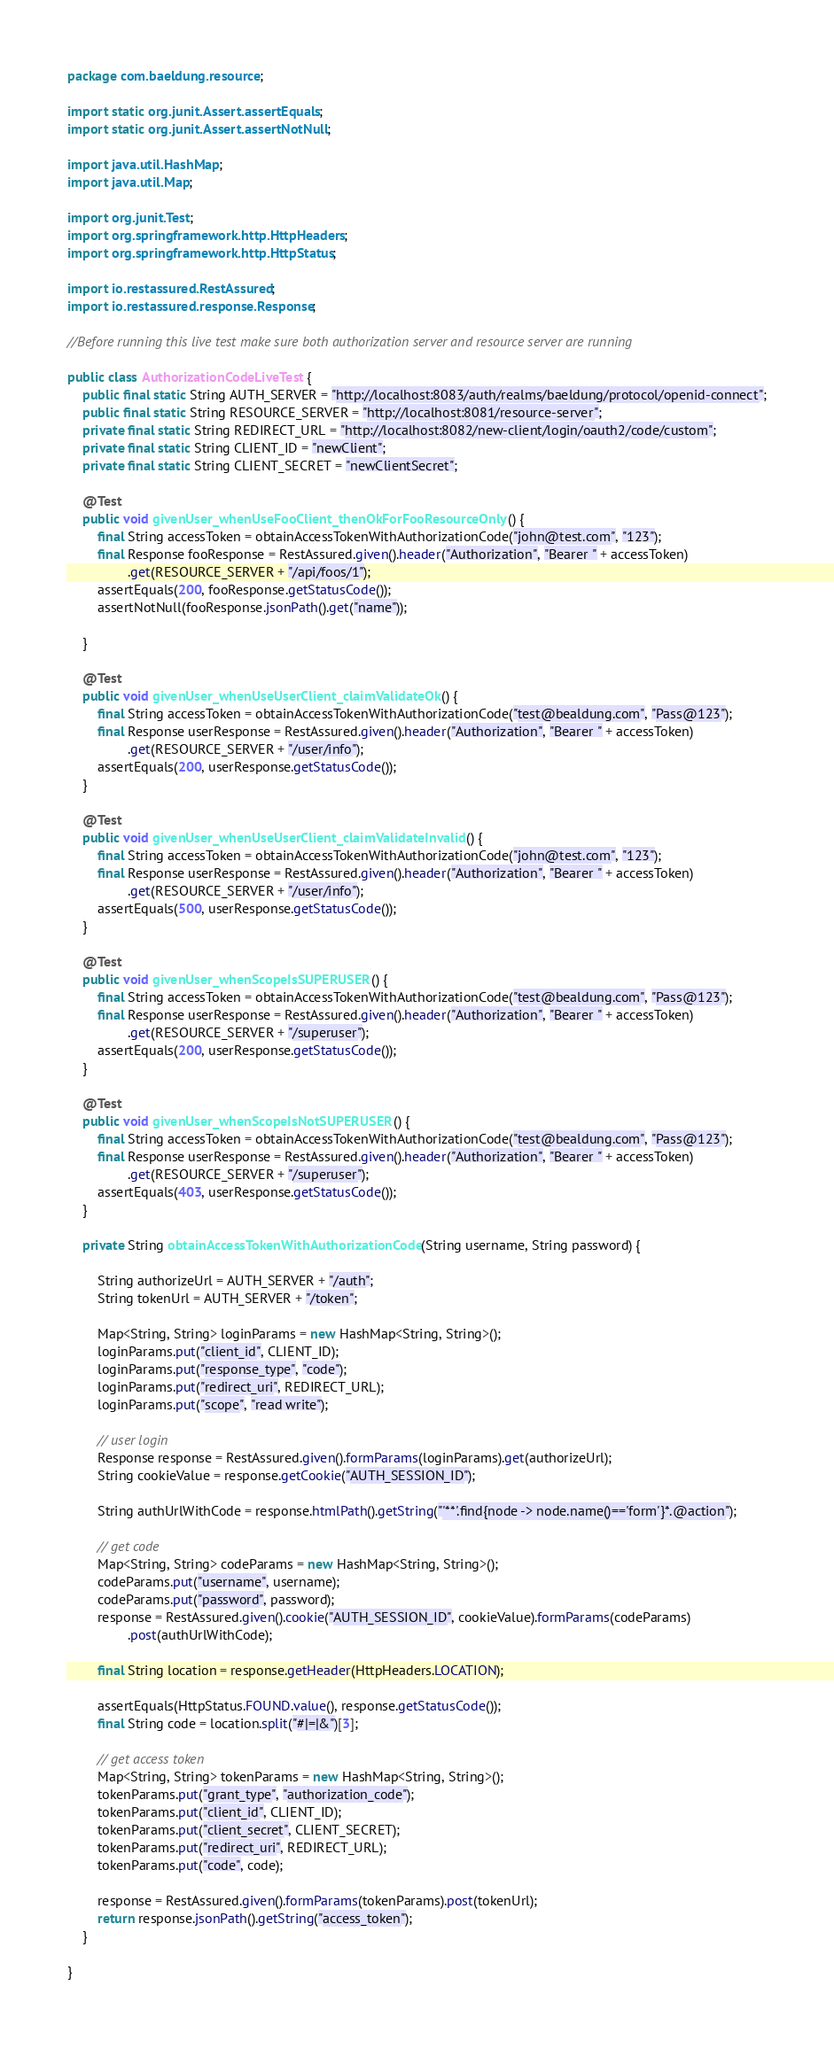<code> <loc_0><loc_0><loc_500><loc_500><_Java_>package com.baeldung.resource;

import static org.junit.Assert.assertEquals;
import static org.junit.Assert.assertNotNull;

import java.util.HashMap;
import java.util.Map;

import org.junit.Test;
import org.springframework.http.HttpHeaders;
import org.springframework.http.HttpStatus;

import io.restassured.RestAssured;
import io.restassured.response.Response;

//Before running this live test make sure both authorization server and resource server are running   

public class AuthorizationCodeLiveTest {
	public final static String AUTH_SERVER = "http://localhost:8083/auth/realms/baeldung/protocol/openid-connect";
	public final static String RESOURCE_SERVER = "http://localhost:8081/resource-server";
	private final static String REDIRECT_URL = "http://localhost:8082/new-client/login/oauth2/code/custom";
	private final static String CLIENT_ID = "newClient";
	private final static String CLIENT_SECRET = "newClientSecret";

	@Test
	public void givenUser_whenUseFooClient_thenOkForFooResourceOnly() {
		final String accessToken = obtainAccessTokenWithAuthorizationCode("john@test.com", "123");
		final Response fooResponse = RestAssured.given().header("Authorization", "Bearer " + accessToken)
				.get(RESOURCE_SERVER + "/api/foos/1");
		assertEquals(200, fooResponse.getStatusCode());
		assertNotNull(fooResponse.jsonPath().get("name"));

	}

	@Test
	public void givenUser_whenUseUserClient_claimValidateOk() {
		final String accessToken = obtainAccessTokenWithAuthorizationCode("test@bealdung.com", "Pass@123");
		final Response userResponse = RestAssured.given().header("Authorization", "Bearer " + accessToken)
				.get(RESOURCE_SERVER + "/user/info");
		assertEquals(200, userResponse.getStatusCode());
	}
	
	@Test
	public void givenUser_whenUseUserClient_claimValidateInvalid() {
		final String accessToken = obtainAccessTokenWithAuthorizationCode("john@test.com", "123");
		final Response userResponse = RestAssured.given().header("Authorization", "Bearer " + accessToken)
				.get(RESOURCE_SERVER + "/user/info");
		assertEquals(500, userResponse.getStatusCode());
	}
	
	@Test
	public void givenUser_whenScopeIsSUPERUSER() {
		final String accessToken = obtainAccessTokenWithAuthorizationCode("test@bealdung.com", "Pass@123");
		final Response userResponse = RestAssured.given().header("Authorization", "Bearer " + accessToken)
				.get(RESOURCE_SERVER + "/superuser");
		assertEquals(200, userResponse.getStatusCode());
	}
	
	@Test
	public void givenUser_whenScopeIsNotSUPERUSER() {
		final String accessToken = obtainAccessTokenWithAuthorizationCode("test@bealdung.com", "Pass@123");
		final Response userResponse = RestAssured.given().header("Authorization", "Bearer " + accessToken)
				.get(RESOURCE_SERVER + "/superuser");
		assertEquals(403, userResponse.getStatusCode());
	}

	private String obtainAccessTokenWithAuthorizationCode(String username, String password) {

		String authorizeUrl = AUTH_SERVER + "/auth";
		String tokenUrl = AUTH_SERVER + "/token";

		Map<String, String> loginParams = new HashMap<String, String>();
		loginParams.put("client_id", CLIENT_ID);
		loginParams.put("response_type", "code");
		loginParams.put("redirect_uri", REDIRECT_URL);
		loginParams.put("scope", "read write");

		// user login
		Response response = RestAssured.given().formParams(loginParams).get(authorizeUrl);
		String cookieValue = response.getCookie("AUTH_SESSION_ID");

		String authUrlWithCode = response.htmlPath().getString("'**'.find{node -> node.name()=='form'}*.@action");

		// get code
		Map<String, String> codeParams = new HashMap<String, String>();
		codeParams.put("username", username);
		codeParams.put("password", password);
		response = RestAssured.given().cookie("AUTH_SESSION_ID", cookieValue).formParams(codeParams)
				.post(authUrlWithCode);

		final String location = response.getHeader(HttpHeaders.LOCATION);

		assertEquals(HttpStatus.FOUND.value(), response.getStatusCode());
		final String code = location.split("#|=|&")[3];

		// get access token
		Map<String, String> tokenParams = new HashMap<String, String>();
		tokenParams.put("grant_type", "authorization_code");
		tokenParams.put("client_id", CLIENT_ID);
		tokenParams.put("client_secret", CLIENT_SECRET);
		tokenParams.put("redirect_uri", REDIRECT_URL);
		tokenParams.put("code", code);

		response = RestAssured.given().formParams(tokenParams).post(tokenUrl);
		return response.jsonPath().getString("access_token");
	}

}
</code> 